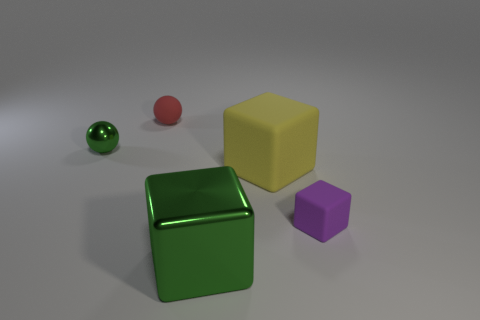Is the shape of the purple rubber thing the same as the green shiny thing that is behind the small purple cube? no 